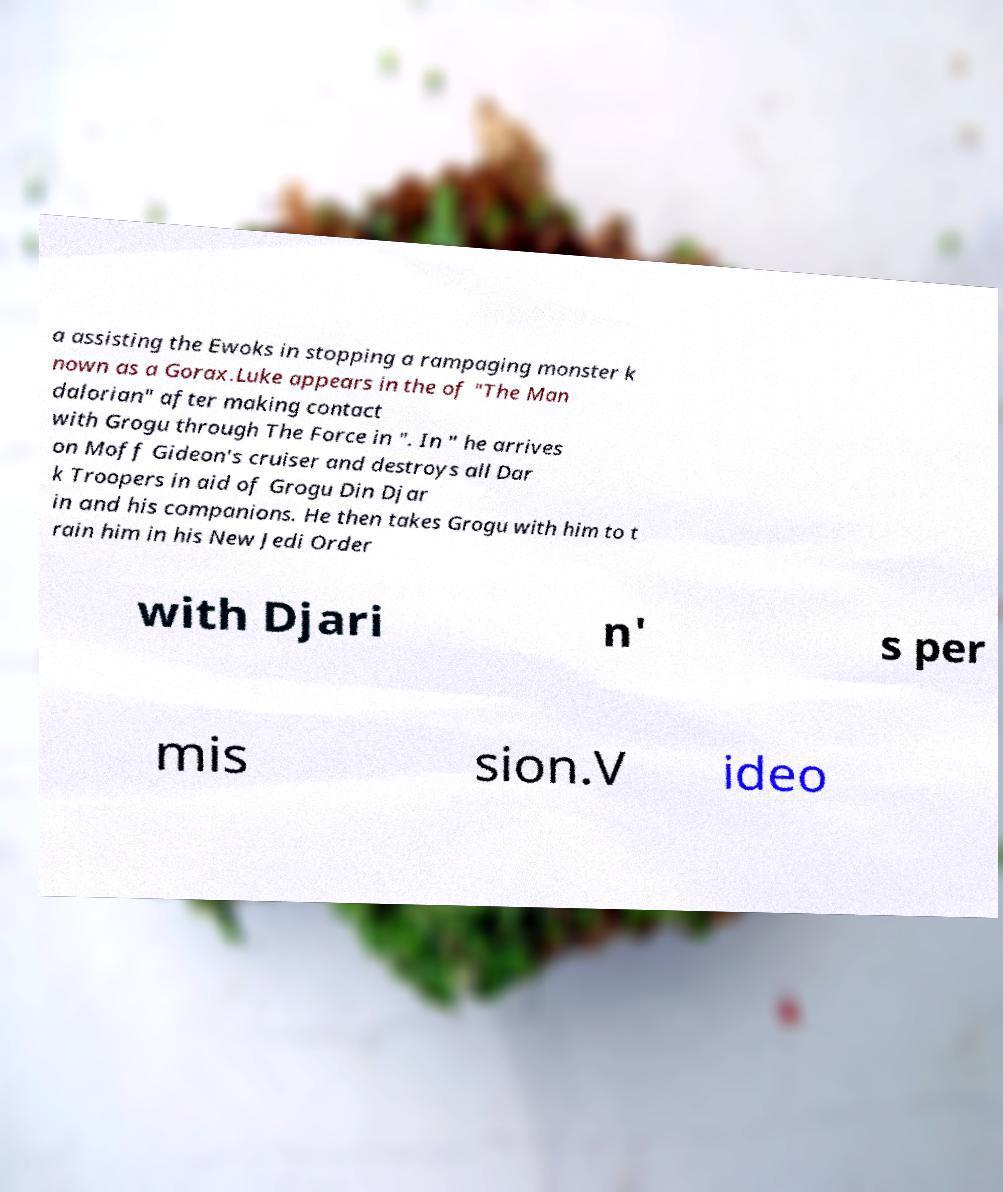Can you accurately transcribe the text from the provided image for me? a assisting the Ewoks in stopping a rampaging monster k nown as a Gorax.Luke appears in the of "The Man dalorian" after making contact with Grogu through The Force in ". In " he arrives on Moff Gideon's cruiser and destroys all Dar k Troopers in aid of Grogu Din Djar in and his companions. He then takes Grogu with him to t rain him in his New Jedi Order with Djari n' s per mis sion.V ideo 